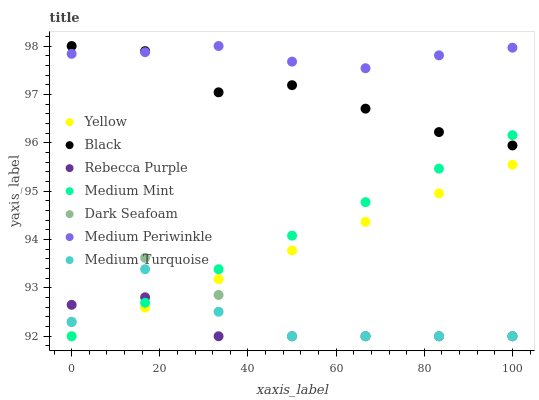Does Rebecca Purple have the minimum area under the curve?
Answer yes or no. Yes. Does Medium Periwinkle have the maximum area under the curve?
Answer yes or no. Yes. Does Yellow have the minimum area under the curve?
Answer yes or no. No. Does Yellow have the maximum area under the curve?
Answer yes or no. No. Is Medium Mint the smoothest?
Answer yes or no. Yes. Is Dark Seafoam the roughest?
Answer yes or no. Yes. Is Medium Periwinkle the smoothest?
Answer yes or no. No. Is Medium Periwinkle the roughest?
Answer yes or no. No. Does Medium Mint have the lowest value?
Answer yes or no. Yes. Does Medium Periwinkle have the lowest value?
Answer yes or no. No. Does Black have the highest value?
Answer yes or no. Yes. Does Yellow have the highest value?
Answer yes or no. No. Is Rebecca Purple less than Black?
Answer yes or no. Yes. Is Black greater than Rebecca Purple?
Answer yes or no. Yes. Does Medium Mint intersect Yellow?
Answer yes or no. Yes. Is Medium Mint less than Yellow?
Answer yes or no. No. Is Medium Mint greater than Yellow?
Answer yes or no. No. Does Rebecca Purple intersect Black?
Answer yes or no. No. 